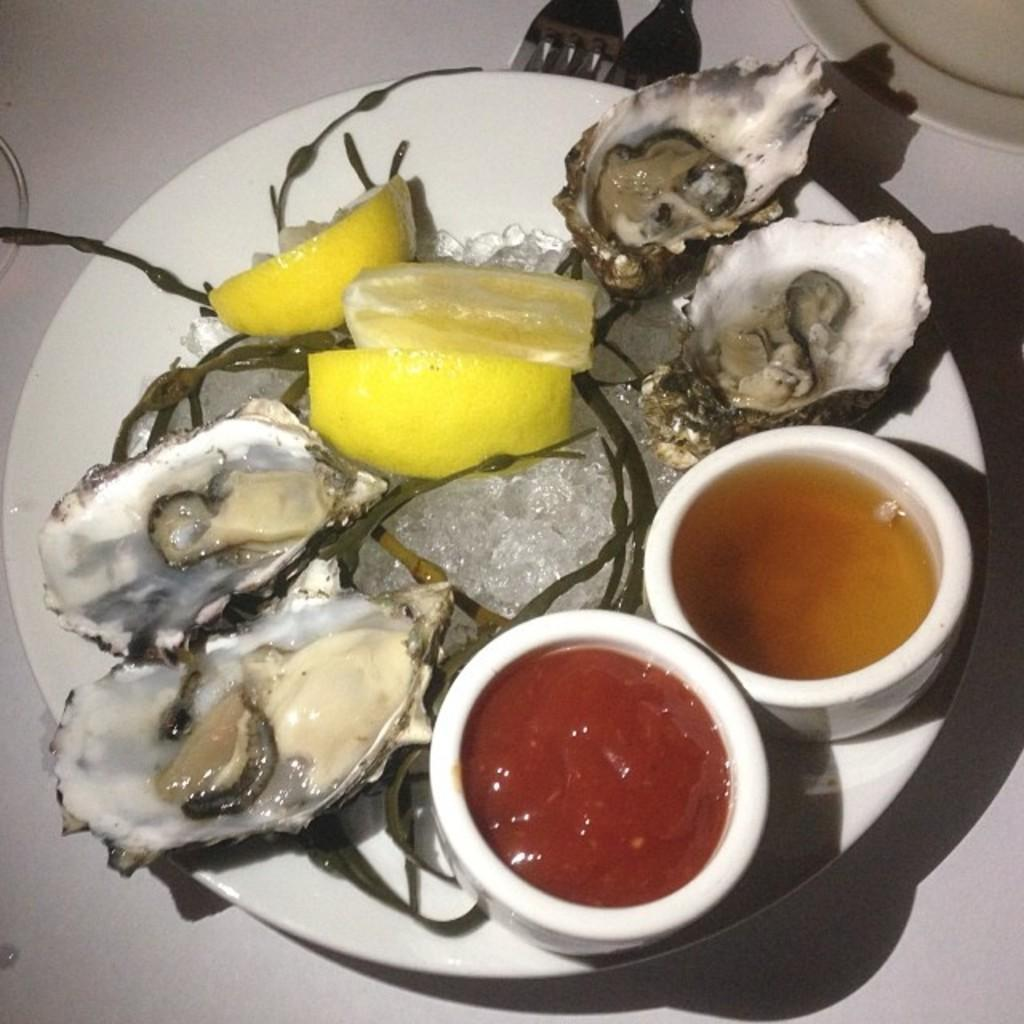What is present on the plate in the image? There is no information about the plate's contents in the provided facts. What type of containers are visible in the image? There are bowls in the image. What type of seafood can be seen in the image? There are oysters in the image. What utensils are present in the image? There are forks in the image. Where are the food items located in the image? The food items are on a platform in the image. Can you tell me how many vegetables are on the feet of the person in the image? There is no person or vegetable present on anyone's feet in the image. What type of balloon can be seen floating above the oysters in the image? There is no balloon present in the image. 